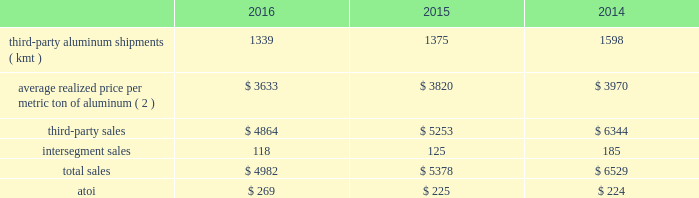Management anticipates that the effective tax rate in 2017 will be between 32% ( 32 % ) and 35% ( 35 % ) .
However , business portfolio actions , changes in the current economic environment , tax legislation or rate changes , currency fluctuations , ability to realize deferred tax assets , movements in stock price impacting tax benefits or deficiencies on stock-based payment awards , and the results of operations in certain taxing jurisdictions may cause this estimated rate to fluctuate .
Segment information arconic 2019s operations consist of three worldwide reportable segments : global rolled products , engineered products and solutions , and transportation and construction solutions ( see below ) .
Segment performance under arconic 2019s management reporting system is evaluated based on a number of factors ; however , the primary measure of performance is the after-tax operating income ( atoi ) of each segment .
Certain items such as the impact of lifo inventory accounting ; metal price lag ( the timing difference created when the average price of metal sold differs from the average cost of the metal when purchased by the respective segment 2014generally when the price of metal increases , metal lag is favorable and when the price of metal decreases , metal lag is unfavorable ) ; interest expense ; noncontrolling interests ; corporate expense ( general administrative and selling expenses of operating the corporate headquarters and other global administrative facilities , along with depreciation and amortization on corporate-owned assets ) ; restructuring and other charges ; and other items , including intersegment profit eliminations , differences between tax rates applicable to the segments and the consolidated effective tax rate , and other nonoperating items such as foreign currency transaction gains/losses and interest income are excluded from segment atoi .
Atoi for all reportable segments totaled $ 1087 in 2016 , $ 986 in 2015 , and $ 983 in 2014 .
The following information provides shipment , sales and atoi data for each reportable segment , as well as certain realized price data , for each of the three years in the period ended december 31 , 2016 .
See note o to the consolidated financial statements in part ii item 8 of this form 10-k for additional information .
Beginning in the first quarter of 2017 , arconic 2019s segment reporting metric will change from atoi to adjusted ebitda .
Global rolled products ( 1 ) .
( 1 ) excludes the warrick , in rolling operations and the equity interest in the rolling mill at the joint venture in saudi arabia , both of which were previously part of the global rolled products segment but became part of alcoa corporation effective november 1 , 2016 .
( 2 ) generally , average realized price per metric ton of aluminum includes two elements : a ) the price of metal ( the underlying base metal component based on quoted prices from the lme , plus a regional premium which represents the incremental price over the base lme component that is associated with physical delivery of metal to a particular region ) , and b ) the conversion price , which represents the incremental price over the metal price component that is associated with converting primary aluminum into sheet and plate .
In this circumstance , the metal price component is a pass-through to this segment 2019s customers with limited exception ( e.g. , fixed-priced contracts , certain regional premiums ) .
The global rolled products segment produces aluminum sheet and plate for a variety of end markets .
Sheet and plate is sold directly to customers and through distributors related to the aerospace , automotive , commercial transportation , packaging , building and construction , and industrial products ( mainly used in the production of machinery and equipment and consumer durables ) end markets .
A small portion of this segment also produces aseptic foil for the packaging end market .
While the customer base for flat-rolled products is large , a significant amount of sales of sheet .
What is the percentual growth of the global products' atoi concerning the total atoi for all segments during the years 2014-2015? 
Rationale: it s the difference between the percentage of global products' atoi of each year .
Computations: ((225 / 986) - (224 / 983))
Answer: 0.00032. 